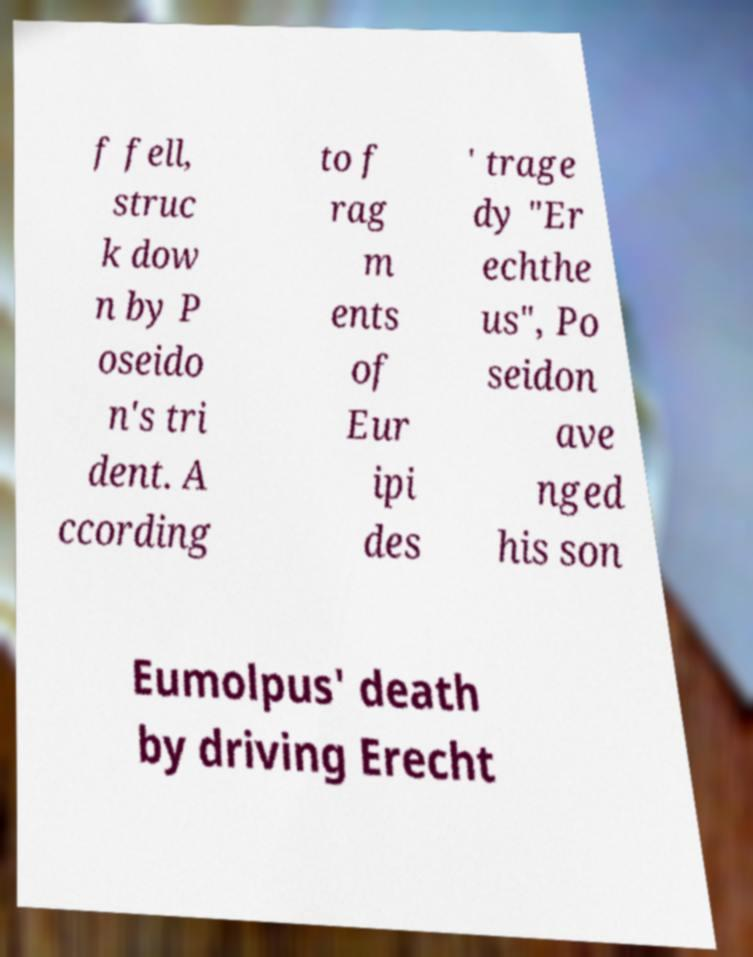Please read and relay the text visible in this image. What does it say? f fell, struc k dow n by P oseido n's tri dent. A ccording to f rag m ents of Eur ipi des ' trage dy "Er echthe us", Po seidon ave nged his son Eumolpus' death by driving Erecht 